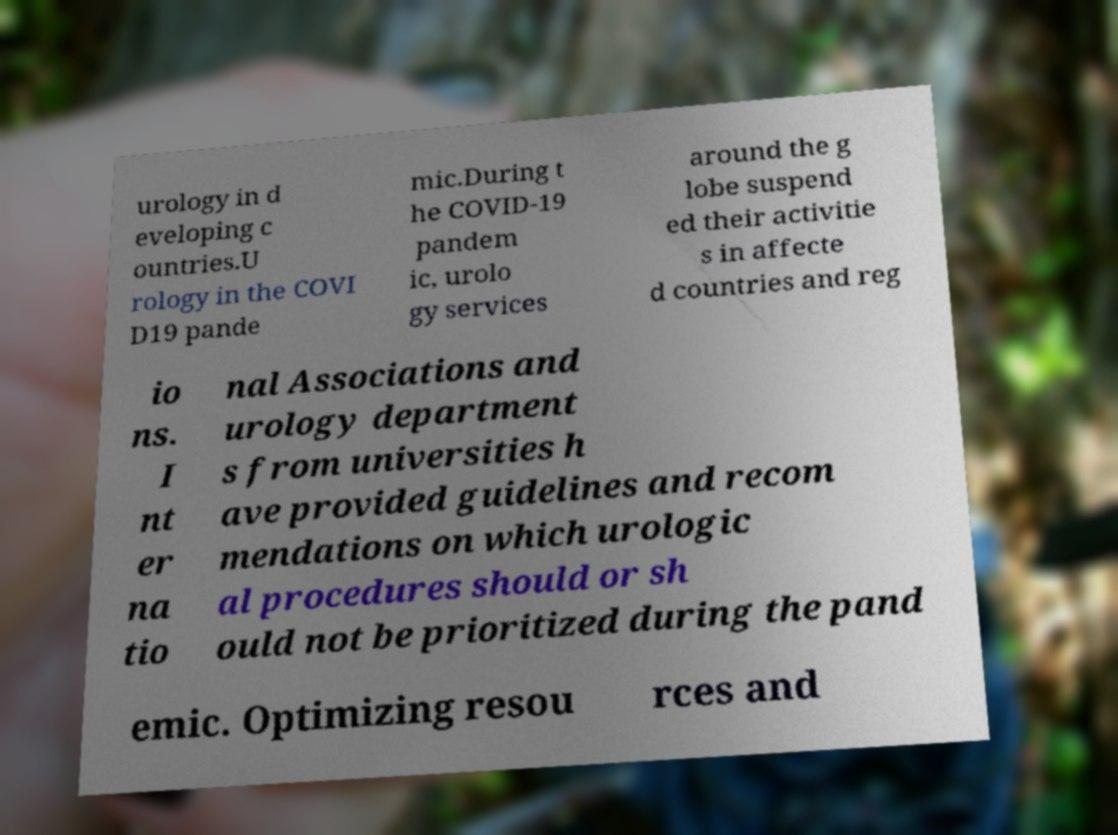Could you extract and type out the text from this image? urology in d eveloping c ountries.U rology in the COVI D19 pande mic.During t he COVID-19 pandem ic, urolo gy services around the g lobe suspend ed their activitie s in affecte d countries and reg io ns. I nt er na tio nal Associations and urology department s from universities h ave provided guidelines and recom mendations on which urologic al procedures should or sh ould not be prioritized during the pand emic. Optimizing resou rces and 